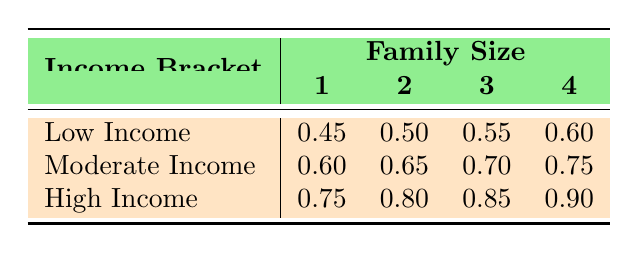What is the Housing Affordability Index for a family of size 2 with low income? From the table, we look at the row for "Low Income" and the column for "Family Size 2", which shows a value of 0.50.
Answer: 0.50 What is the highest Housing Affordability Index shown in the table? The highest value can be found in the row "High Income" and "Family Size 4", which shows 0.90.
Answer: 0.90 Is the Housing Affordability Index for a moderate income household with a family size of 3 greater than 0.70? Checking the table for "Moderate Income" and "Family Size 3", the value is 0.70, which means the statement is false.
Answer: No What is the average Housing Affordability Index for families with a size of 4 across all income brackets? To find the average, we take the values from the table for size 4: 0.60 (low), 0.75 (moderate), and 0.90 (high). Adding these gives 0.60 + 0.75 + 0.90 = 2.25. Dividing by 3 (the number of data points) gives us 2.25 / 3 = 0.75.
Answer: 0.75 Does a one-person household with high income have a higher Housing Affordability Index than a three-person household with low income? The table shows 0.75 for "High Income" and "Family Size 1", and 0.55 for "Low Income" and "Family Size 3". Since 0.75 is greater than 0.55, the statement is true.
Answer: Yes What is the difference in the Housing Affordability Index between a low income family of size 1 and a high income family of size 1? From the table, the Index for low income family size 1 is 0.45 and for high income family size 1 is 0.75. The difference is 0.75 - 0.45 = 0.30.
Answer: 0.30 What is the Housing Affordability Index for a family of size 4 with moderate income? Looking at the row for "Moderate Income" and column for "Family Size 4", the value is 0.75.
Answer: 0.75 Is it true that a two-person household with high income has a Housing Affordability Index that equals the average for one-person households across the income brackets? The value for a two-person household with high income is 0.80. The average for one-person households is (0.45 + 0.60 + 0.75) / 3 = 0.60. Since 0.80 is greater than 0.60, the statement is false.
Answer: No 